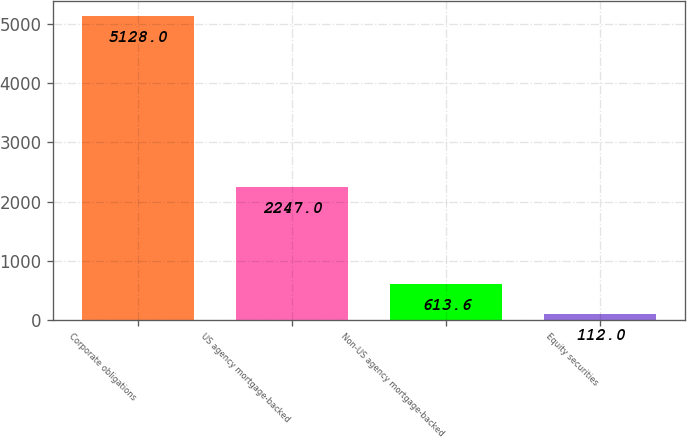<chart> <loc_0><loc_0><loc_500><loc_500><bar_chart><fcel>Corporate obligations<fcel>US agency mortgage-backed<fcel>Non-US agency mortgage-backed<fcel>Equity securities<nl><fcel>5128<fcel>2247<fcel>613.6<fcel>112<nl></chart> 